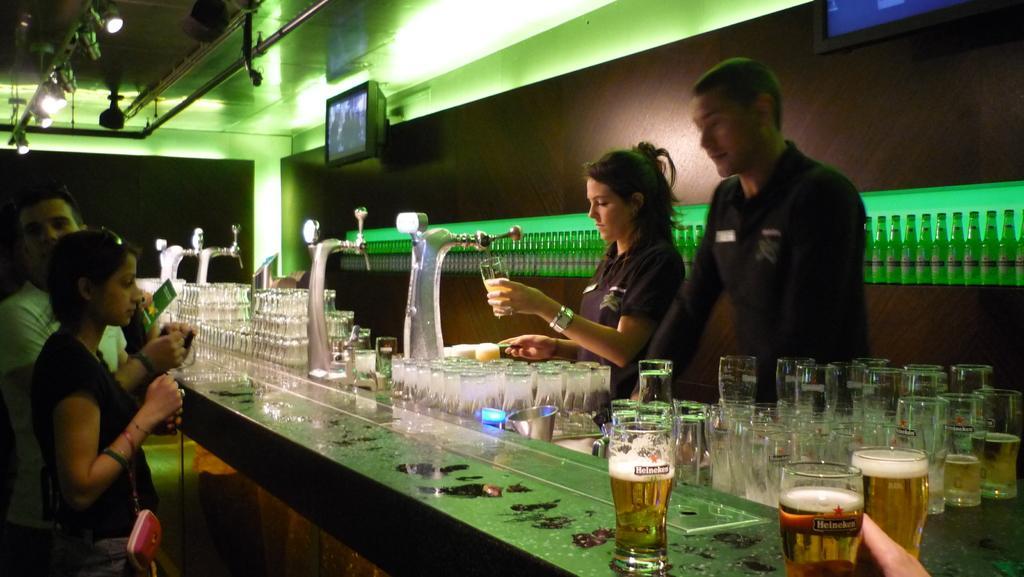Please provide a concise description of this image. This picture contains glasses which are placed on the table. Woman in blue t-shirt holding glass is feeling cold drink in a glass. Behind her, we see many glass bottles on the table and in front of in front of her, we see woman and man standing. Woman is carrying a bag. On top of the picture, we see television and on the right left top, we see the roof of the room. 